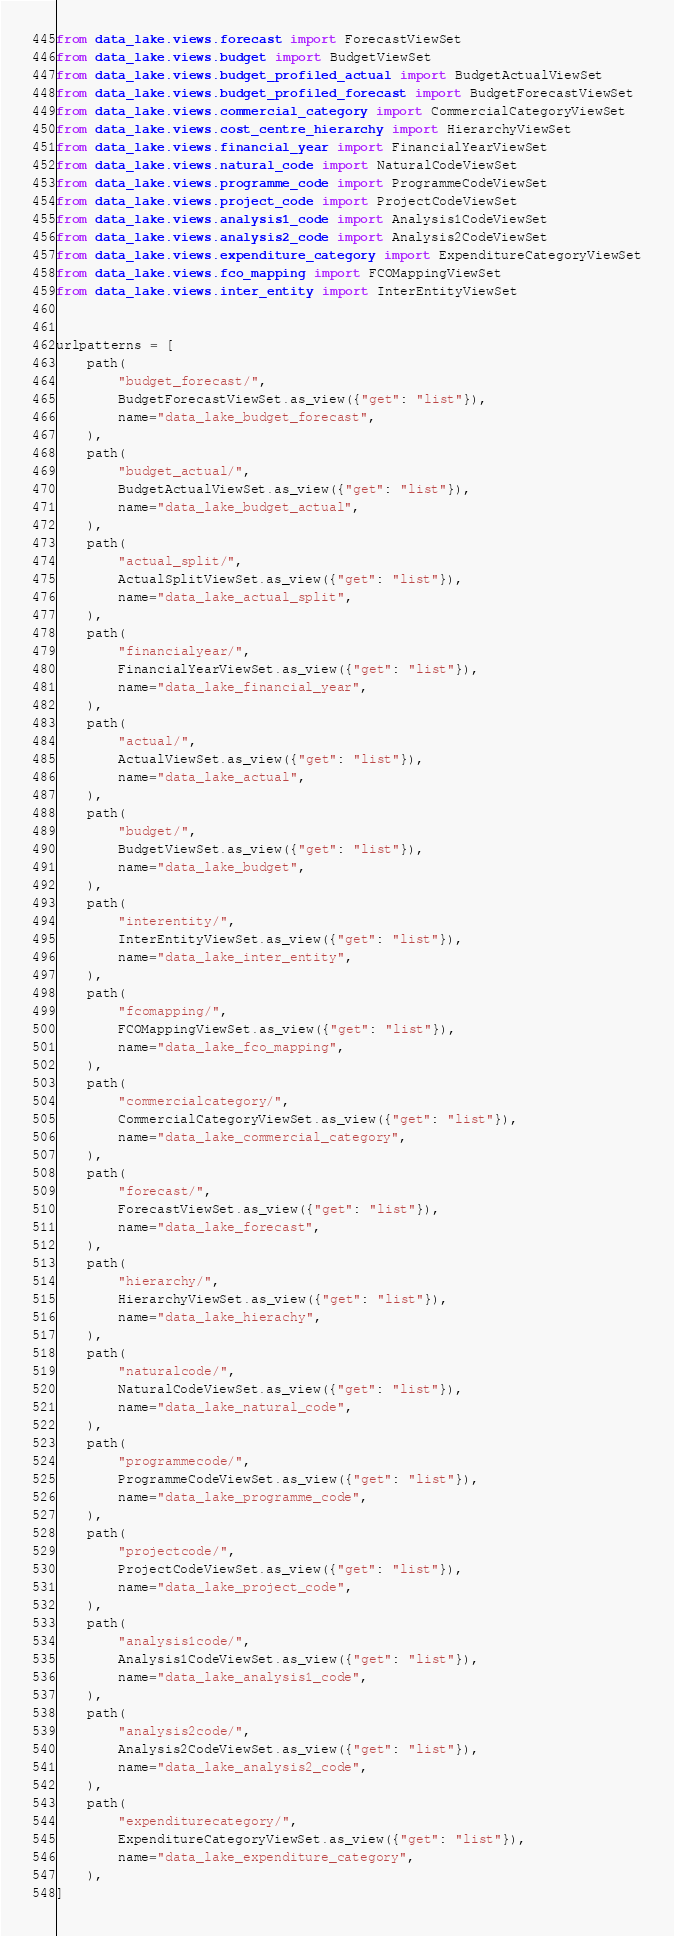<code> <loc_0><loc_0><loc_500><loc_500><_Python_>from data_lake.views.forecast import ForecastViewSet
from data_lake.views.budget import BudgetViewSet
from data_lake.views.budget_profiled_actual import BudgetActualViewSet
from data_lake.views.budget_profiled_forecast import BudgetForecastViewSet
from data_lake.views.commercial_category import CommercialCategoryViewSet
from data_lake.views.cost_centre_hierarchy import HierarchyViewSet
from data_lake.views.financial_year import FinancialYearViewSet
from data_lake.views.natural_code import NaturalCodeViewSet
from data_lake.views.programme_code import ProgrammeCodeViewSet
from data_lake.views.project_code import ProjectCodeViewSet
from data_lake.views.analysis1_code import Analysis1CodeViewSet
from data_lake.views.analysis2_code import Analysis2CodeViewSet
from data_lake.views.expenditure_category import ExpenditureCategoryViewSet
from data_lake.views.fco_mapping import FCOMappingViewSet
from data_lake.views.inter_entity import InterEntityViewSet


urlpatterns = [
    path(
        "budget_forecast/",
        BudgetForecastViewSet.as_view({"get": "list"}),
        name="data_lake_budget_forecast",
    ),
    path(
        "budget_actual/",
        BudgetActualViewSet.as_view({"get": "list"}),
        name="data_lake_budget_actual",
    ),
    path(
        "actual_split/",
        ActualSplitViewSet.as_view({"get": "list"}),
        name="data_lake_actual_split",
    ),
    path(
        "financialyear/",
        FinancialYearViewSet.as_view({"get": "list"}),
        name="data_lake_financial_year",
    ),
    path(
        "actual/",
        ActualViewSet.as_view({"get": "list"}),
        name="data_lake_actual",
    ),
    path(
        "budget/",
        BudgetViewSet.as_view({"get": "list"}),
        name="data_lake_budget",
    ),
    path(
        "interentity/",
        InterEntityViewSet.as_view({"get": "list"}),
        name="data_lake_inter_entity",
    ),
    path(
        "fcomapping/",
        FCOMappingViewSet.as_view({"get": "list"}),
        name="data_lake_fco_mapping",
    ),
    path(
        "commercialcategory/",
        CommercialCategoryViewSet.as_view({"get": "list"}),
        name="data_lake_commercial_category",
    ),
    path(
        "forecast/",
        ForecastViewSet.as_view({"get": "list"}),
        name="data_lake_forecast",
    ),
    path(
        "hierarchy/",
        HierarchyViewSet.as_view({"get": "list"}),
        name="data_lake_hierachy",
    ),
    path(
        "naturalcode/",
        NaturalCodeViewSet.as_view({"get": "list"}),
        name="data_lake_natural_code",
    ),
    path(
        "programmecode/",
        ProgrammeCodeViewSet.as_view({"get": "list"}),
        name="data_lake_programme_code",
    ),
    path(
        "projectcode/",
        ProjectCodeViewSet.as_view({"get": "list"}),
        name="data_lake_project_code",
    ),
    path(
        "analysis1code/",
        Analysis1CodeViewSet.as_view({"get": "list"}),
        name="data_lake_analysis1_code",
    ),
    path(
        "analysis2code/",
        Analysis2CodeViewSet.as_view({"get": "list"}),
        name="data_lake_analysis2_code",
    ),
    path(
        "expenditurecategory/",
        ExpenditureCategoryViewSet.as_view({"get": "list"}),
        name="data_lake_expenditure_category",
    ),
]
</code> 